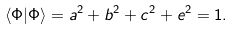<formula> <loc_0><loc_0><loc_500><loc_500>\langle \Phi | \Phi \rangle = a ^ { 2 } + b ^ { 2 } + c ^ { 2 } + e ^ { 2 } = 1 .</formula> 